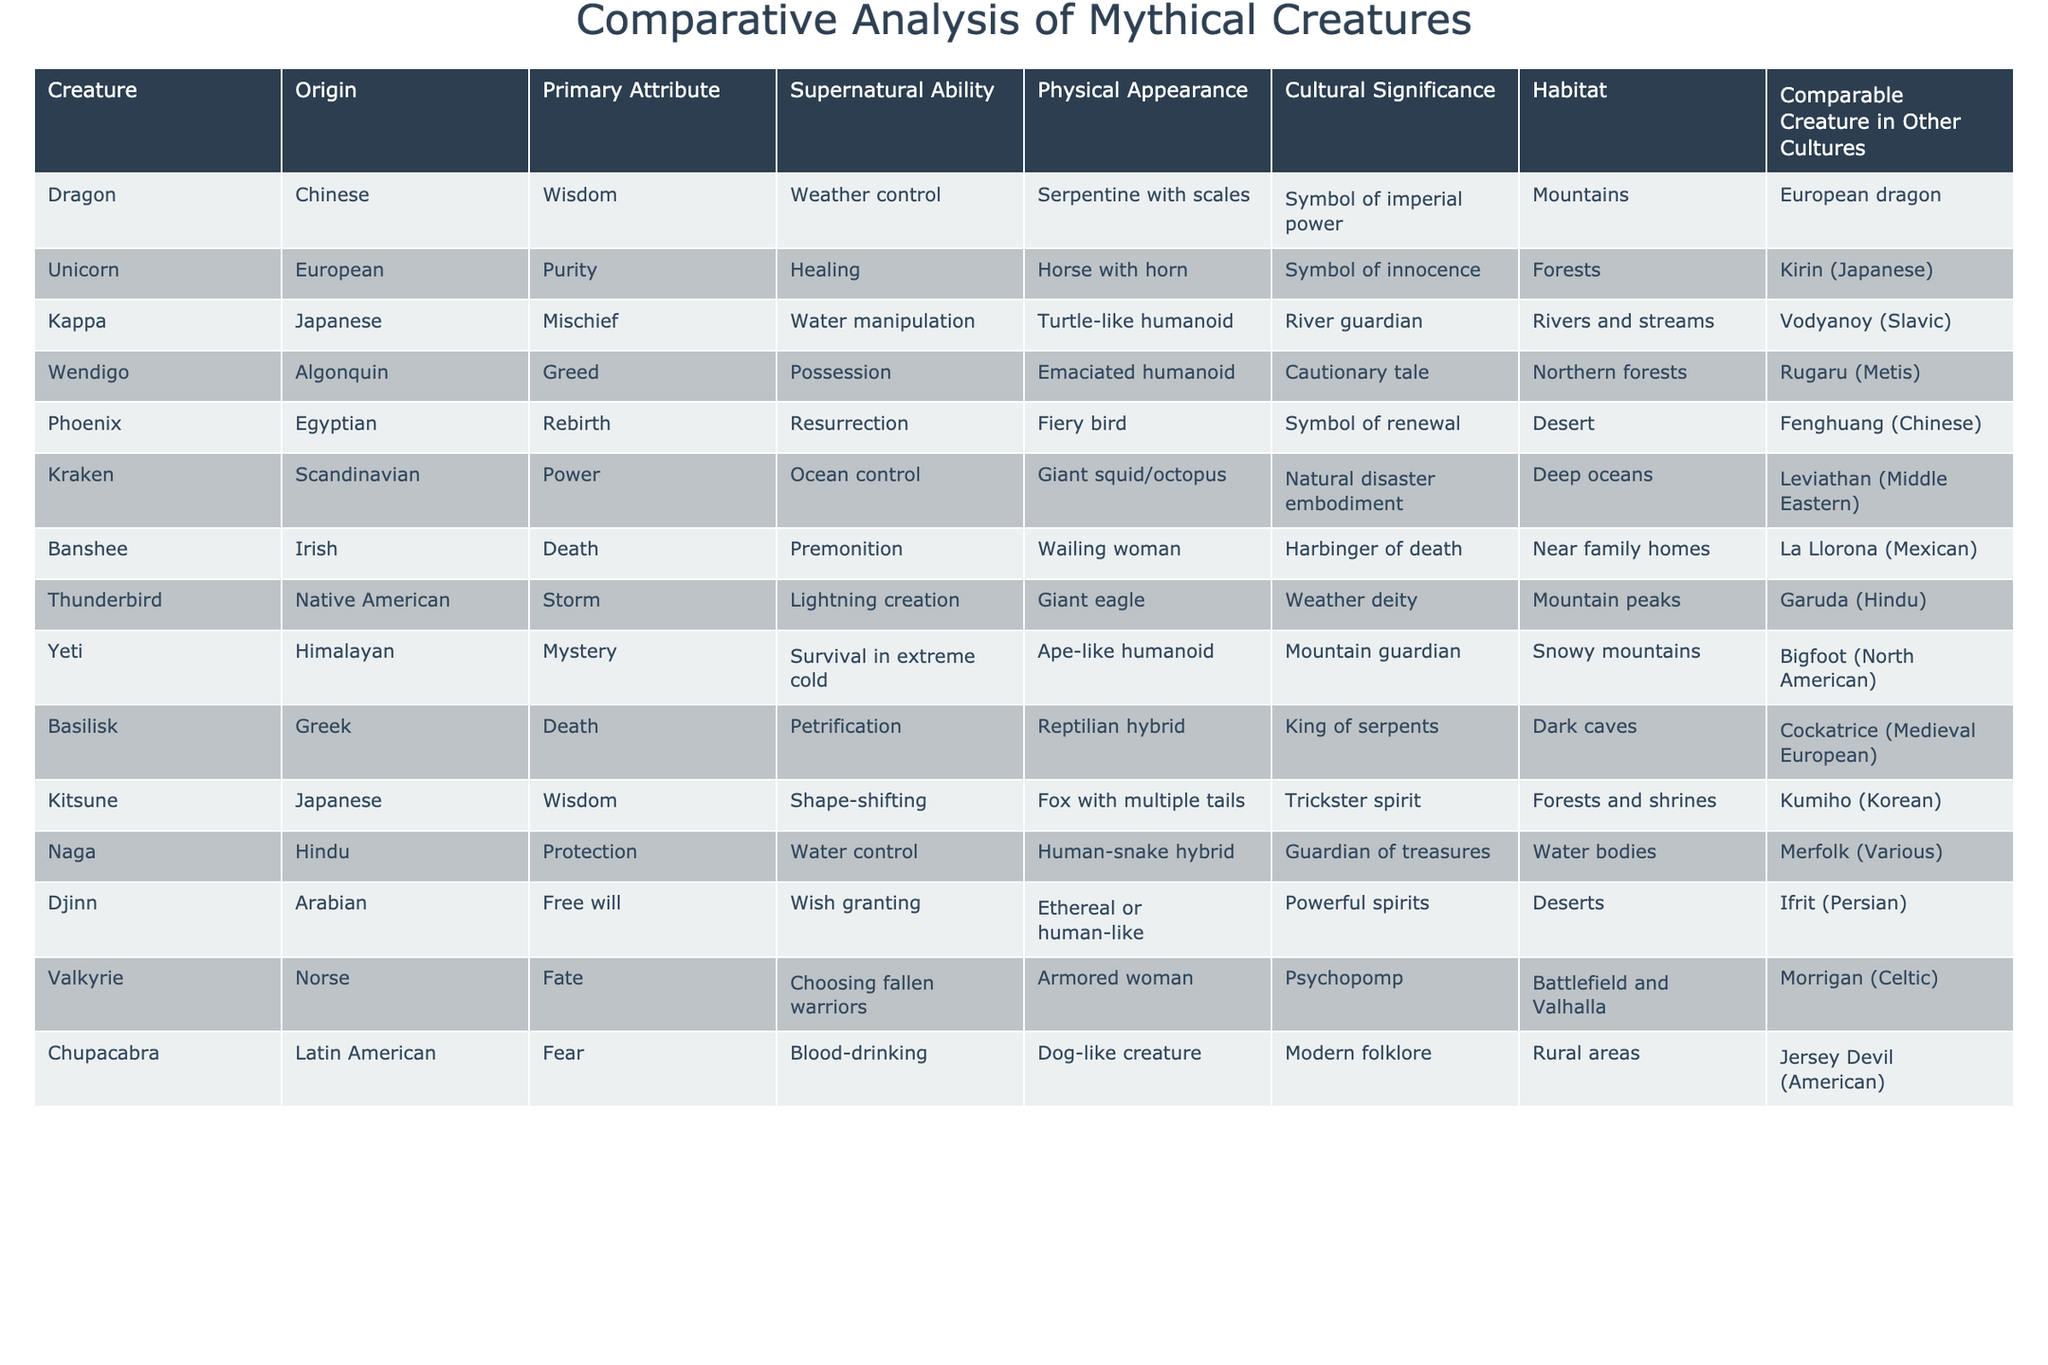What is the primary attribute of the Dragon? The table lists "Wisdom" as the primary attribute associated with the Dragon.
Answer: Wisdom Which creature is associated with resurrection? The table shows that the Phoenix has the supernatural ability of resurrection.
Answer: Phoenix Are there any creatures associated with greed? The Wendigo is listed as having the primary attribute of greed in the table.
Answer: Yes What creatures share the ability of shape-shifting? The table indicates that the Kitsune can shape-shift, and there is no other creature listed with this ability.
Answer: Kitsune How many mythical creatures have a habitat in mountains? Both the Dragon and the Thunderbird are listed with a habitat in mountains, giving a total of two creatures.
Answer: 2 Which creature is comparable to the Yeti in other cultures? The table presents Bigfoot as the creature comparable to the Yeti in other cultures.
Answer: Bigfoot What is the physical appearance of the Banshee? According to the table, the Banshee is described as a "Wailing woman."
Answer: Wailing woman Does the Unicorn have a comparable creature in other cultures? The table states that the Unicorn is comparable to the Kirin in Japanese culture.
Answer: Yes Which two creatures are associated with water manipulation? The Kappa and Naga both possess water manipulation as their supernatural ability, as indicated in the table.
Answer: Kappa, Naga Is the Valkyrie a creature associated with the battlefield? The Valkyrie is described in the table as a psychopomp found in the battlefield and Valhalla.
Answer: Yes What is the cultural significance of the Kraken? The Kraken is described in the table as an embodiment of natural disaster, highlighting its cultural significance.
Answer: Natural disaster embodiment Name all the mythical creatures whose primary attributes involve death. The table lists the Banshee and the Basilisk as creatures with primary attributes of death.
Answer: Banshee, Basilisk Which creature represents a symbol of purity and what is its origin? The Unicorn symbolizes purity and has European origins, as per the table information.
Answer: Unicorn, European How many creatures are listed as having human-like physical appearances? The Djinn and Kappa are noted in the table with human-like appearances, leading to a count of two.
Answer: 2 What is the supernatural ability of the Naga? The table specifies that the Naga's supernatural ability involves water control.
Answer: Water control Which creature represents a symbol of innocence? The Unicorn is identified in the table as the creature that symbolizes innocence.
Answer: Unicorn What do the creatures Kappa and Vodyanoy have in common? Both the Kappa and Vodyanoy are associated with rivers and have water manipulation abilities.
Answer: River habitat, water manipulation List all creatures that have their comparable counterpart in Japanese folklore. The Unicorn is comparable to the Kirin, and the Kitsune is compared to the Kumiho in the table.
Answer: Unicorn, Kitsune 